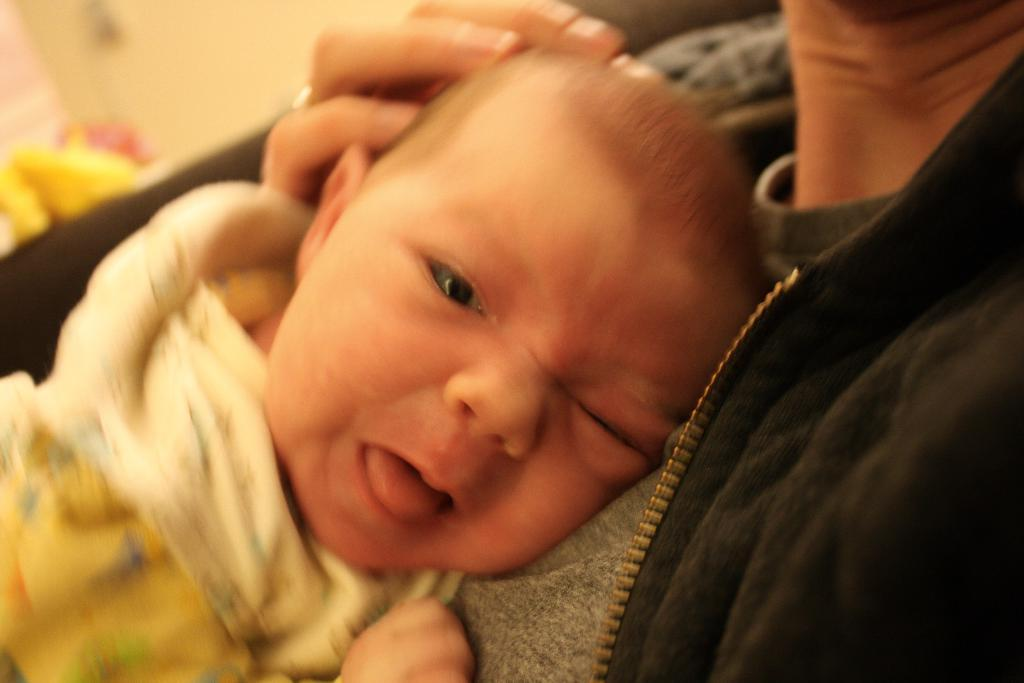What is the main subject of the image? There is a child in the image. What is the child doing in the image? The child is lying on a person's chest. What type of bridge can be seen in the image? There is no bridge present in the image; it features a child lying on a person's chest. 